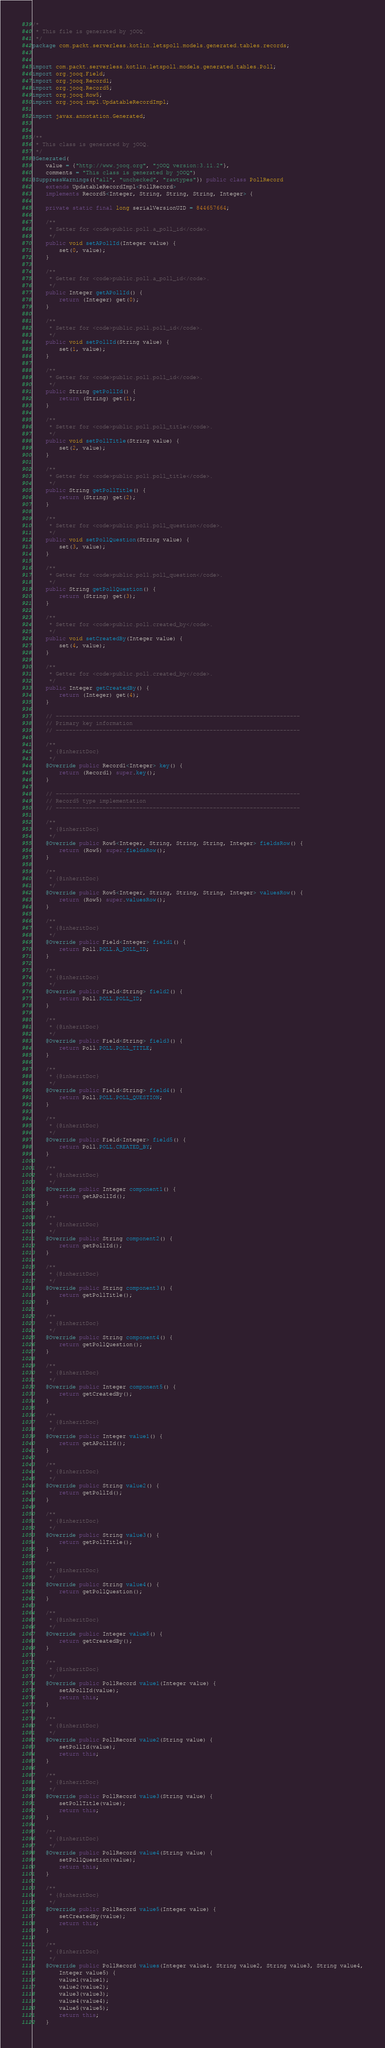<code> <loc_0><loc_0><loc_500><loc_500><_Java_>/*
 * This file is generated by jOOQ.
 */
package com.packt.serverless.kotlin.letspoll.models.generated.tables.records;


import com.packt.serverless.kotlin.letspoll.models.generated.tables.Poll;
import org.jooq.Field;
import org.jooq.Record1;
import org.jooq.Record5;
import org.jooq.Row5;
import org.jooq.impl.UpdatableRecordImpl;

import javax.annotation.Generated;


/**
 * This class is generated by jOOQ.
 */
@Generated(
    value = {"http://www.jooq.org", "jOOQ version:3.11.2"},
    comments = "This class is generated by jOOQ")
@SuppressWarnings({"all", "unchecked", "rawtypes"}) public class PollRecord
    extends UpdatableRecordImpl<PollRecord>
    implements Record5<Integer, String, String, String, Integer> {

    private static final long serialVersionUID = 844657664;

    /**
     * Setter for <code>public.poll.a_poll_id</code>.
     */
    public void setAPollId(Integer value) {
        set(0, value);
    }

    /**
     * Getter for <code>public.poll.a_poll_id</code>.
     */
    public Integer getAPollId() {
        return (Integer) get(0);
    }

    /**
     * Setter for <code>public.poll.poll_id</code>.
     */
    public void setPollId(String value) {
        set(1, value);
    }

    /**
     * Getter for <code>public.poll.poll_id</code>.
     */
    public String getPollId() {
        return (String) get(1);
    }

    /**
     * Setter for <code>public.poll.poll_title</code>.
     */
    public void setPollTitle(String value) {
        set(2, value);
    }

    /**
     * Getter for <code>public.poll.poll_title</code>.
     */
    public String getPollTitle() {
        return (String) get(2);
    }

    /**
     * Setter for <code>public.poll.poll_question</code>.
     */
    public void setPollQuestion(String value) {
        set(3, value);
    }

    /**
     * Getter for <code>public.poll.poll_question</code>.
     */
    public String getPollQuestion() {
        return (String) get(3);
    }

    /**
     * Setter for <code>public.poll.created_by</code>.
     */
    public void setCreatedBy(Integer value) {
        set(4, value);
    }

    /**
     * Getter for <code>public.poll.created_by</code>.
     */
    public Integer getCreatedBy() {
        return (Integer) get(4);
    }

    // -------------------------------------------------------------------------
    // Primary key information
    // -------------------------------------------------------------------------

    /**
     * {@inheritDoc}
     */
    @Override public Record1<Integer> key() {
        return (Record1) super.key();
    }

    // -------------------------------------------------------------------------
    // Record5 type implementation
    // -------------------------------------------------------------------------

    /**
     * {@inheritDoc}
     */
    @Override public Row5<Integer, String, String, String, Integer> fieldsRow() {
        return (Row5) super.fieldsRow();
    }

    /**
     * {@inheritDoc}
     */
    @Override public Row5<Integer, String, String, String, Integer> valuesRow() {
        return (Row5) super.valuesRow();
    }

    /**
     * {@inheritDoc}
     */
    @Override public Field<Integer> field1() {
        return Poll.POLL.A_POLL_ID;
    }

    /**
     * {@inheritDoc}
     */
    @Override public Field<String> field2() {
        return Poll.POLL.POLL_ID;
    }

    /**
     * {@inheritDoc}
     */
    @Override public Field<String> field3() {
        return Poll.POLL.POLL_TITLE;
    }

    /**
     * {@inheritDoc}
     */
    @Override public Field<String> field4() {
        return Poll.POLL.POLL_QUESTION;
    }

    /**
     * {@inheritDoc}
     */
    @Override public Field<Integer> field5() {
        return Poll.POLL.CREATED_BY;
    }

    /**
     * {@inheritDoc}
     */
    @Override public Integer component1() {
        return getAPollId();
    }

    /**
     * {@inheritDoc}
     */
    @Override public String component2() {
        return getPollId();
    }

    /**
     * {@inheritDoc}
     */
    @Override public String component3() {
        return getPollTitle();
    }

    /**
     * {@inheritDoc}
     */
    @Override public String component4() {
        return getPollQuestion();
    }

    /**
     * {@inheritDoc}
     */
    @Override public Integer component5() {
        return getCreatedBy();
    }

    /**
     * {@inheritDoc}
     */
    @Override public Integer value1() {
        return getAPollId();
    }

    /**
     * {@inheritDoc}
     */
    @Override public String value2() {
        return getPollId();
    }

    /**
     * {@inheritDoc}
     */
    @Override public String value3() {
        return getPollTitle();
    }

    /**
     * {@inheritDoc}
     */
    @Override public String value4() {
        return getPollQuestion();
    }

    /**
     * {@inheritDoc}
     */
    @Override public Integer value5() {
        return getCreatedBy();
    }

    /**
     * {@inheritDoc}
     */
    @Override public PollRecord value1(Integer value) {
        setAPollId(value);
        return this;
    }

    /**
     * {@inheritDoc}
     */
    @Override public PollRecord value2(String value) {
        setPollId(value);
        return this;
    }

    /**
     * {@inheritDoc}
     */
    @Override public PollRecord value3(String value) {
        setPollTitle(value);
        return this;
    }

    /**
     * {@inheritDoc}
     */
    @Override public PollRecord value4(String value) {
        setPollQuestion(value);
        return this;
    }

    /**
     * {@inheritDoc}
     */
    @Override public PollRecord value5(Integer value) {
        setCreatedBy(value);
        return this;
    }

    /**
     * {@inheritDoc}
     */
    @Override public PollRecord values(Integer value1, String value2, String value3, String value4,
        Integer value5) {
        value1(value1);
        value2(value2);
        value3(value3);
        value4(value4);
        value5(value5);
        return this;
    }
</code> 